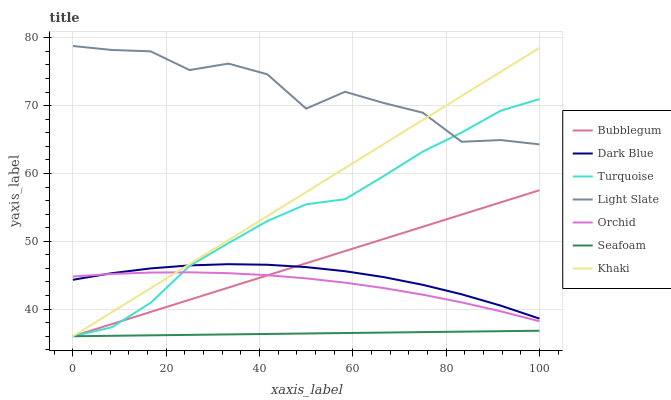Does Seafoam have the minimum area under the curve?
Answer yes or no. Yes. Does Khaki have the minimum area under the curve?
Answer yes or no. No. Does Khaki have the maximum area under the curve?
Answer yes or no. No. Is Khaki the smoothest?
Answer yes or no. No. Is Khaki the roughest?
Answer yes or no. No. Does Light Slate have the lowest value?
Answer yes or no. No. Does Khaki have the highest value?
Answer yes or no. No. Is Orchid less than Light Slate?
Answer yes or no. Yes. Is Light Slate greater than Orchid?
Answer yes or no. Yes. Does Orchid intersect Light Slate?
Answer yes or no. No. 